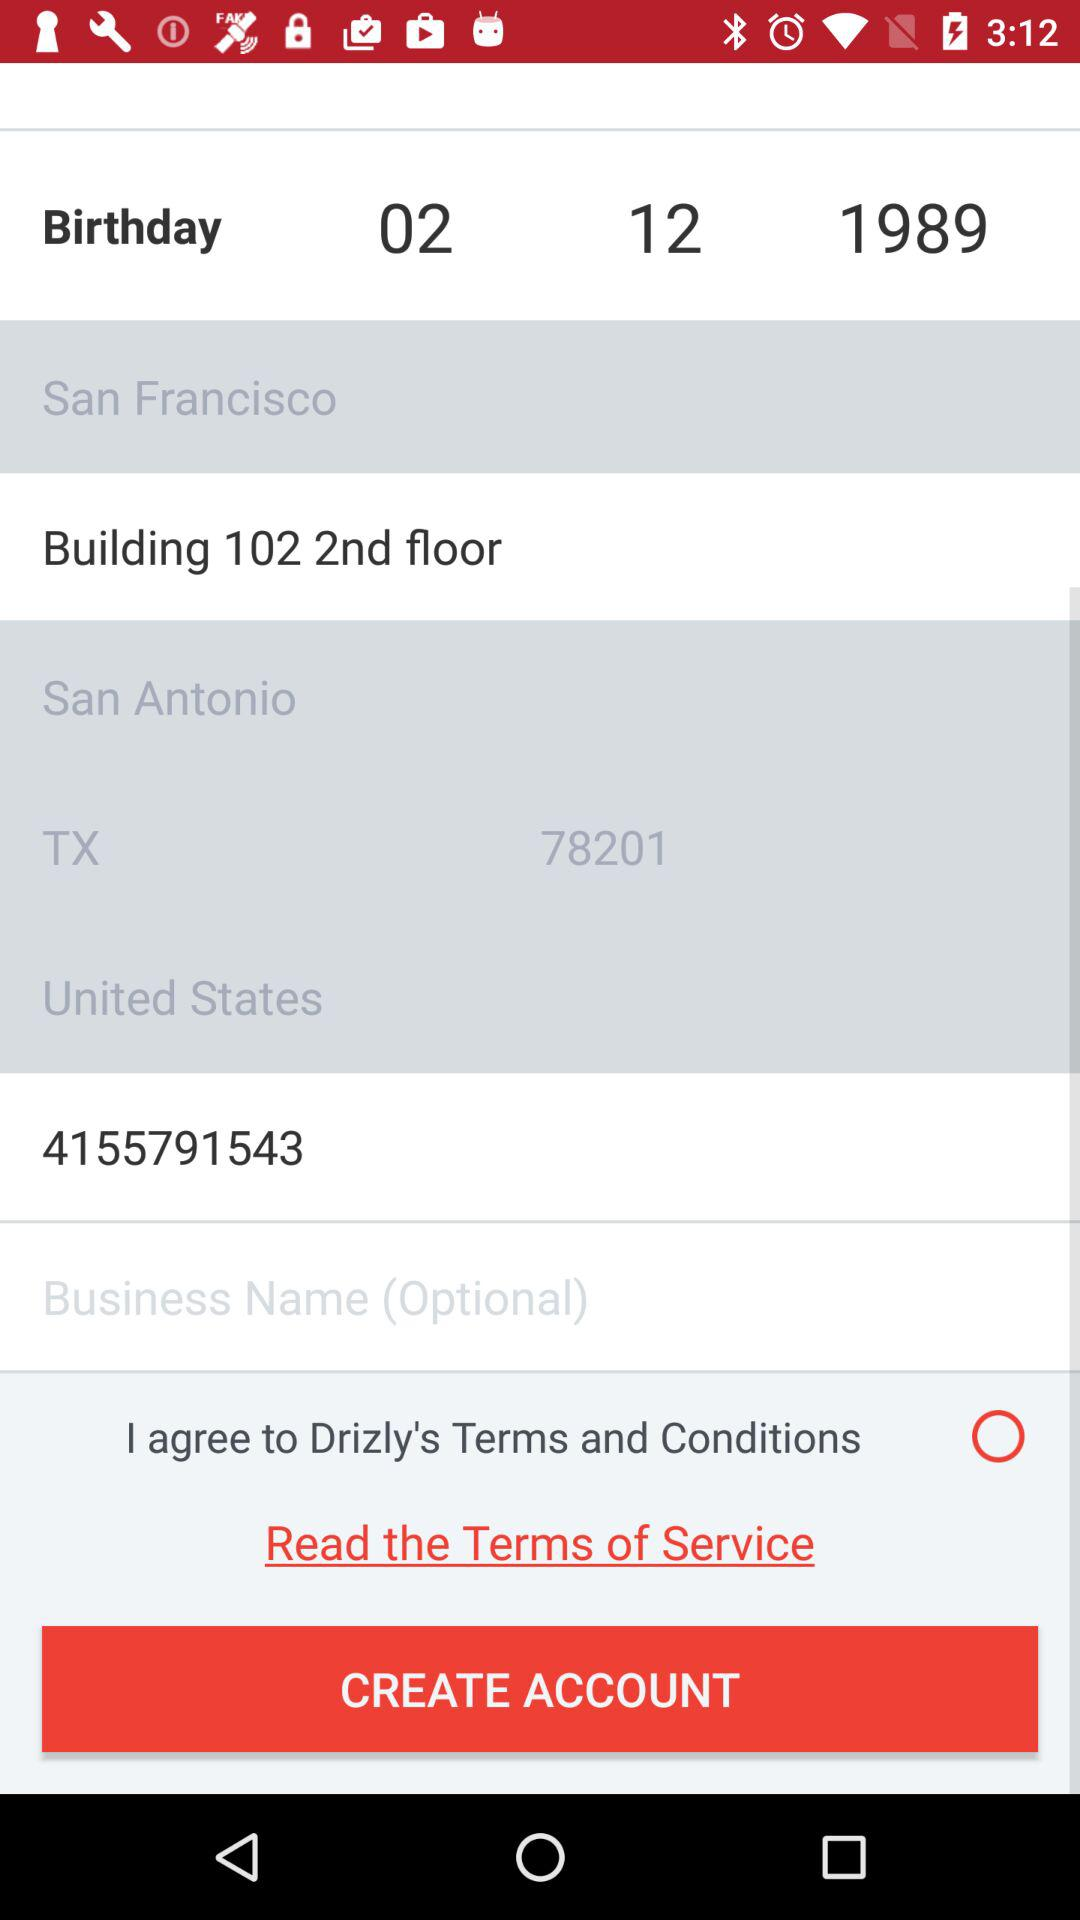What is the date of birth? The date of birth is December 2, 1989. 